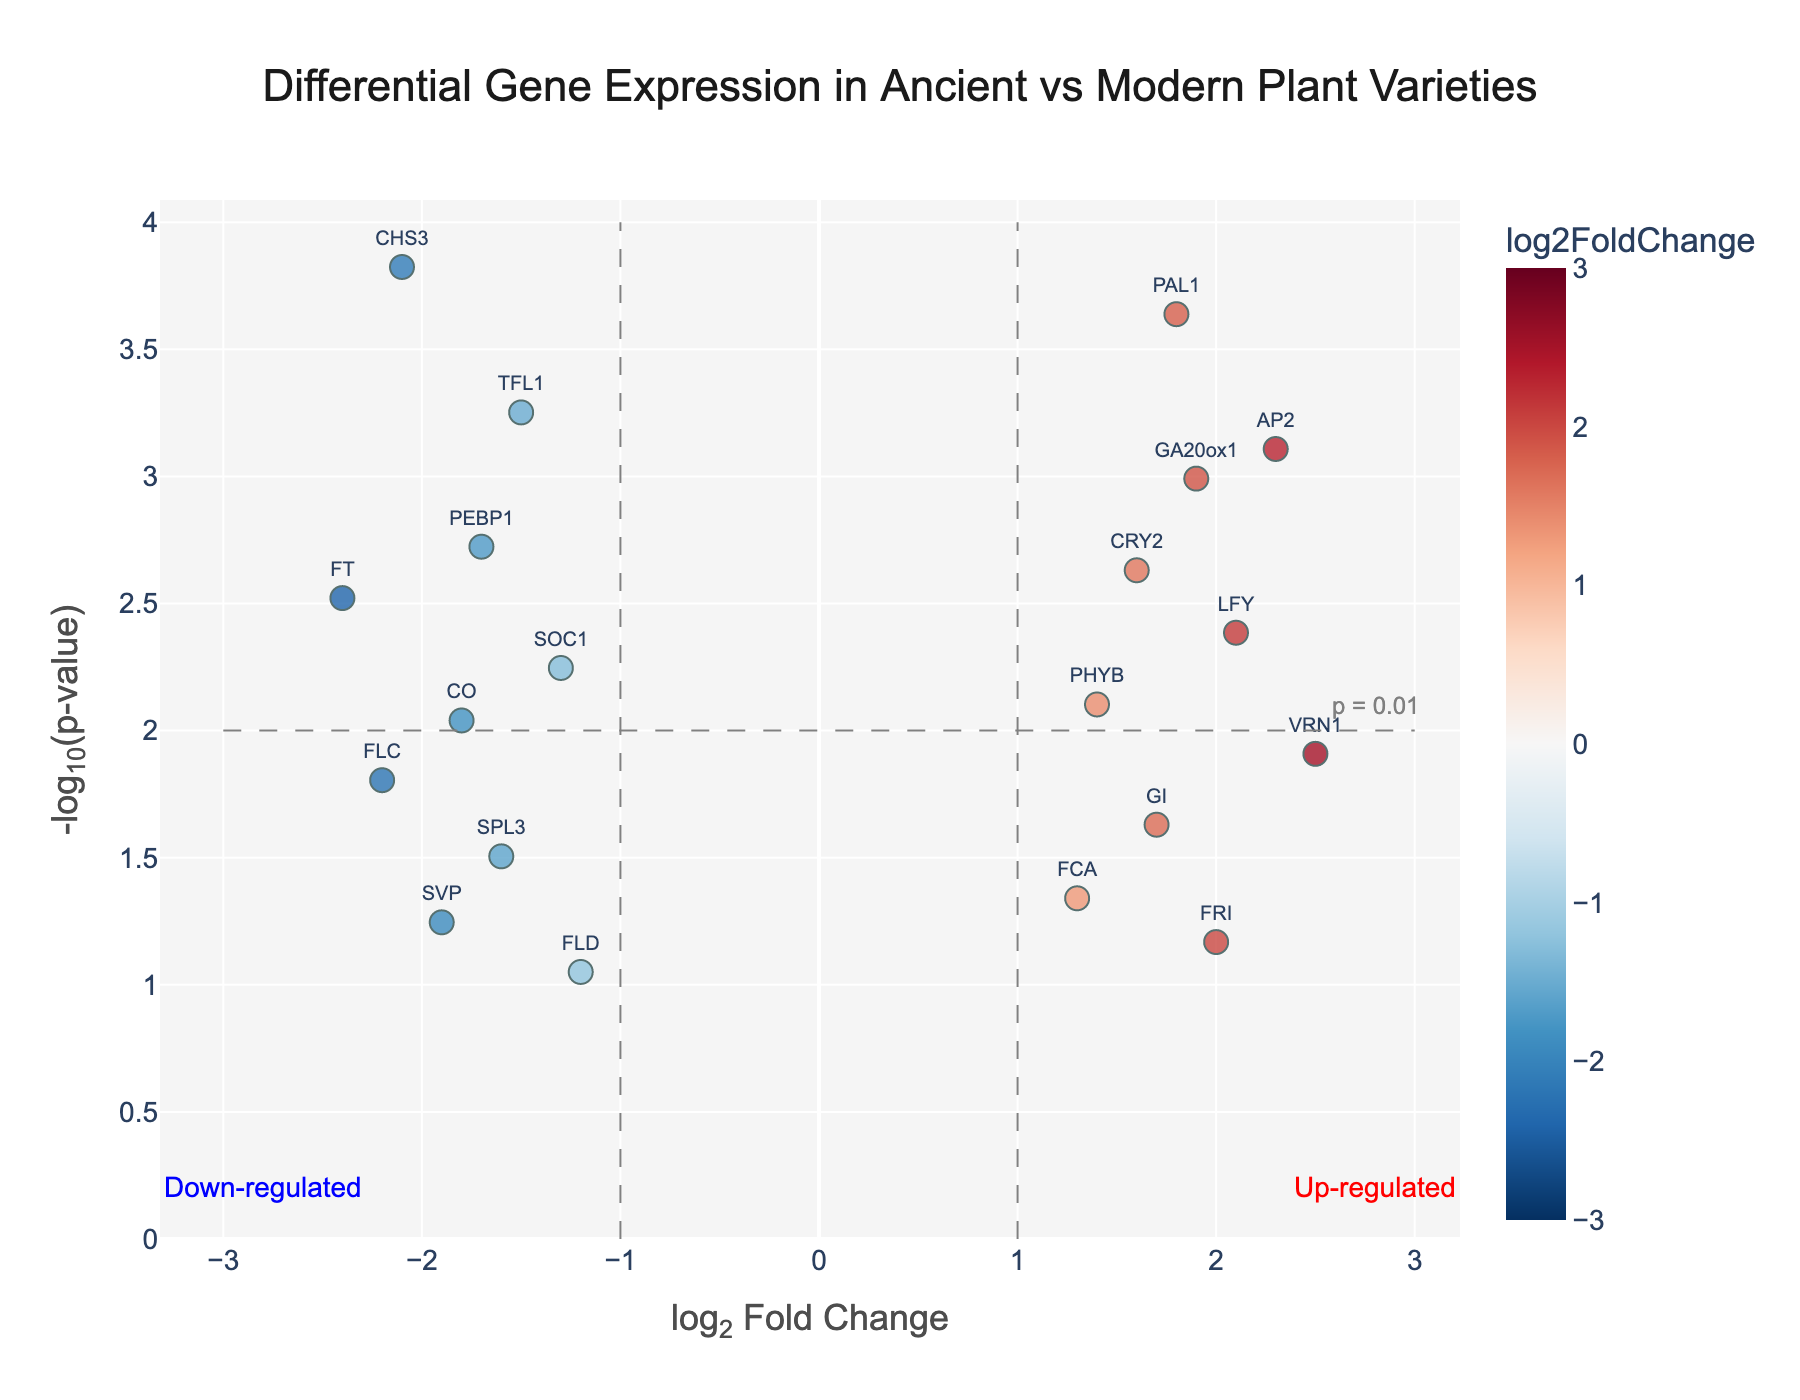Which gene has the highest log2 fold change? The highest log2 fold change is at 2.5, and the gene associated with this value is VRN1.
Answer: VRN1 Which gene is the most significantly down-regulated? The most significantly down-regulated gene will have the highest -log10(pvalue) among those with negative log2 fold change. CHS3 has a log2 fold change of -2.1 and a -log10(pvalue) of approximately 3.82, making it the most significantly down-regulated gene.
Answer: CHS3 How many genes are significantly up-regulated with a p-value less than 0.01? To determine this, look for data points with positive log2 fold change and a -log10(pvalue) greater than 2 (which corresponds to a p-value less than 0.01). Those genes are PAL1, AP2, GA20ox1, and LFY.
Answer: 4 What is the log2 fold change of the gene TFL1? Locate the gene TFL1 on the plot, which has a log2 fold change value of -1.5.
Answer: -1.5 Which gene has the lowest -log10(pvalue)? The lowest -log10(pvalue) indicates the highest p-value. FLD has a -log10(pvalue) of approximately 1.05, which is the lowest among all genes.
Answer: FLD Which gene pairs have similar log2 fold changes but differ significantly in p-values? Compare the genes' log2 fold changes while checking the difference in -log10(pvalue). For example, CO and PEBP1 both have log2 fold changes close to -1.7 and -1.8, respectively, but their p-values differ significantly, with CO having a lower -log10(pvalue).
Answer: CO, PEBP1 What’s the average log2 fold change of all genes? Sum up all log2 fold change values: -2.1 + 1.8 - 1.5 + 2.3 + 1.9 - 1.7 + 1.6 - 2.4 + 2.1 - 1.3 + 1.4 - 1.8 + 2.5 - 2.2 + 1.7 - 1.6 + 1.3 - 1.9 + 2.0 - 1.2 = -1.1. Then, divide by the number of genes (20). The average log2 fold change is -1.1 / 20 = -0.055.
Answer: -0.055 Which gene is the closest to the threshold of being considered significantly up-regulated? (considering p-value < 0.01 and log2 fold change > 1) The threshold defined as a p-value < 0.01 corresponds to -log10(pvalue) > 2 and log2 fold change > 1. The gene closest to this point without surpassing it is LFY.
Answer: LFY 